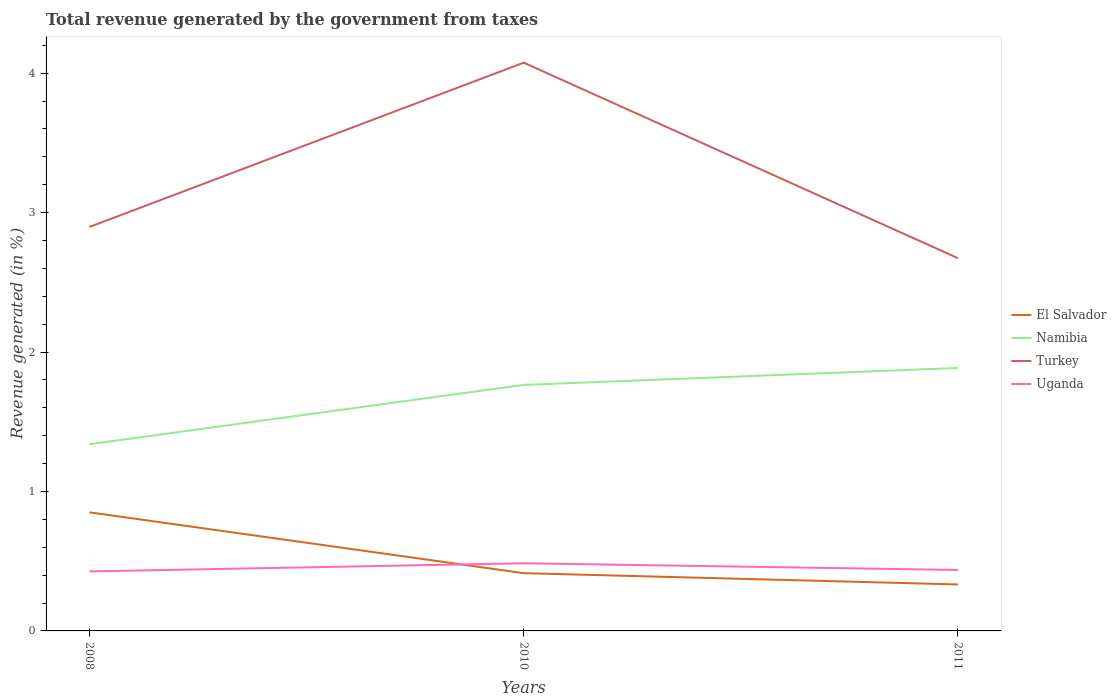Is the number of lines equal to the number of legend labels?
Provide a succinct answer. Yes. Across all years, what is the maximum total revenue generated in Turkey?
Your answer should be very brief. 2.67. What is the total total revenue generated in Turkey in the graph?
Make the answer very short. 1.4. What is the difference between the highest and the second highest total revenue generated in El Salvador?
Make the answer very short. 0.52. What is the difference between the highest and the lowest total revenue generated in Uganda?
Your response must be concise. 1. How many years are there in the graph?
Ensure brevity in your answer.  3. What is the difference between two consecutive major ticks on the Y-axis?
Keep it short and to the point. 1. Are the values on the major ticks of Y-axis written in scientific E-notation?
Offer a terse response. No. Does the graph contain grids?
Offer a terse response. No. How are the legend labels stacked?
Your answer should be very brief. Vertical. What is the title of the graph?
Offer a very short reply. Total revenue generated by the government from taxes. What is the label or title of the Y-axis?
Give a very brief answer. Revenue generated (in %). What is the Revenue generated (in %) in El Salvador in 2008?
Provide a short and direct response. 0.85. What is the Revenue generated (in %) of Namibia in 2008?
Your answer should be very brief. 1.34. What is the Revenue generated (in %) in Turkey in 2008?
Make the answer very short. 2.9. What is the Revenue generated (in %) of Uganda in 2008?
Make the answer very short. 0.43. What is the Revenue generated (in %) in El Salvador in 2010?
Provide a short and direct response. 0.41. What is the Revenue generated (in %) of Namibia in 2010?
Give a very brief answer. 1.76. What is the Revenue generated (in %) of Turkey in 2010?
Offer a terse response. 4.08. What is the Revenue generated (in %) of Uganda in 2010?
Your response must be concise. 0.49. What is the Revenue generated (in %) of El Salvador in 2011?
Your answer should be compact. 0.33. What is the Revenue generated (in %) of Namibia in 2011?
Provide a short and direct response. 1.89. What is the Revenue generated (in %) of Turkey in 2011?
Give a very brief answer. 2.67. What is the Revenue generated (in %) in Uganda in 2011?
Offer a very short reply. 0.44. Across all years, what is the maximum Revenue generated (in %) of El Salvador?
Make the answer very short. 0.85. Across all years, what is the maximum Revenue generated (in %) in Namibia?
Offer a terse response. 1.89. Across all years, what is the maximum Revenue generated (in %) in Turkey?
Ensure brevity in your answer.  4.08. Across all years, what is the maximum Revenue generated (in %) in Uganda?
Provide a short and direct response. 0.49. Across all years, what is the minimum Revenue generated (in %) in El Salvador?
Your answer should be compact. 0.33. Across all years, what is the minimum Revenue generated (in %) in Namibia?
Ensure brevity in your answer.  1.34. Across all years, what is the minimum Revenue generated (in %) in Turkey?
Offer a terse response. 2.67. Across all years, what is the minimum Revenue generated (in %) in Uganda?
Offer a terse response. 0.43. What is the total Revenue generated (in %) in El Salvador in the graph?
Keep it short and to the point. 1.6. What is the total Revenue generated (in %) in Namibia in the graph?
Provide a short and direct response. 4.99. What is the total Revenue generated (in %) of Turkey in the graph?
Offer a very short reply. 9.65. What is the total Revenue generated (in %) of Uganda in the graph?
Your response must be concise. 1.35. What is the difference between the Revenue generated (in %) in El Salvador in 2008 and that in 2010?
Give a very brief answer. 0.44. What is the difference between the Revenue generated (in %) in Namibia in 2008 and that in 2010?
Your answer should be very brief. -0.43. What is the difference between the Revenue generated (in %) in Turkey in 2008 and that in 2010?
Your answer should be compact. -1.18. What is the difference between the Revenue generated (in %) in Uganda in 2008 and that in 2010?
Ensure brevity in your answer.  -0.06. What is the difference between the Revenue generated (in %) in El Salvador in 2008 and that in 2011?
Provide a succinct answer. 0.52. What is the difference between the Revenue generated (in %) of Namibia in 2008 and that in 2011?
Your response must be concise. -0.55. What is the difference between the Revenue generated (in %) in Turkey in 2008 and that in 2011?
Your answer should be very brief. 0.22. What is the difference between the Revenue generated (in %) in Uganda in 2008 and that in 2011?
Your answer should be very brief. -0.01. What is the difference between the Revenue generated (in %) of El Salvador in 2010 and that in 2011?
Keep it short and to the point. 0.08. What is the difference between the Revenue generated (in %) of Namibia in 2010 and that in 2011?
Provide a short and direct response. -0.12. What is the difference between the Revenue generated (in %) in Turkey in 2010 and that in 2011?
Provide a short and direct response. 1.4. What is the difference between the Revenue generated (in %) in Uganda in 2010 and that in 2011?
Provide a succinct answer. 0.05. What is the difference between the Revenue generated (in %) of El Salvador in 2008 and the Revenue generated (in %) of Namibia in 2010?
Ensure brevity in your answer.  -0.91. What is the difference between the Revenue generated (in %) in El Salvador in 2008 and the Revenue generated (in %) in Turkey in 2010?
Your answer should be very brief. -3.22. What is the difference between the Revenue generated (in %) of El Salvador in 2008 and the Revenue generated (in %) of Uganda in 2010?
Keep it short and to the point. 0.37. What is the difference between the Revenue generated (in %) in Namibia in 2008 and the Revenue generated (in %) in Turkey in 2010?
Make the answer very short. -2.74. What is the difference between the Revenue generated (in %) in Namibia in 2008 and the Revenue generated (in %) in Uganda in 2010?
Offer a very short reply. 0.85. What is the difference between the Revenue generated (in %) of Turkey in 2008 and the Revenue generated (in %) of Uganda in 2010?
Ensure brevity in your answer.  2.41. What is the difference between the Revenue generated (in %) in El Salvador in 2008 and the Revenue generated (in %) in Namibia in 2011?
Give a very brief answer. -1.04. What is the difference between the Revenue generated (in %) in El Salvador in 2008 and the Revenue generated (in %) in Turkey in 2011?
Provide a short and direct response. -1.82. What is the difference between the Revenue generated (in %) in El Salvador in 2008 and the Revenue generated (in %) in Uganda in 2011?
Give a very brief answer. 0.41. What is the difference between the Revenue generated (in %) of Namibia in 2008 and the Revenue generated (in %) of Turkey in 2011?
Ensure brevity in your answer.  -1.33. What is the difference between the Revenue generated (in %) of Namibia in 2008 and the Revenue generated (in %) of Uganda in 2011?
Keep it short and to the point. 0.9. What is the difference between the Revenue generated (in %) of Turkey in 2008 and the Revenue generated (in %) of Uganda in 2011?
Make the answer very short. 2.46. What is the difference between the Revenue generated (in %) in El Salvador in 2010 and the Revenue generated (in %) in Namibia in 2011?
Give a very brief answer. -1.47. What is the difference between the Revenue generated (in %) in El Salvador in 2010 and the Revenue generated (in %) in Turkey in 2011?
Your response must be concise. -2.26. What is the difference between the Revenue generated (in %) in El Salvador in 2010 and the Revenue generated (in %) in Uganda in 2011?
Keep it short and to the point. -0.02. What is the difference between the Revenue generated (in %) of Namibia in 2010 and the Revenue generated (in %) of Turkey in 2011?
Make the answer very short. -0.91. What is the difference between the Revenue generated (in %) of Namibia in 2010 and the Revenue generated (in %) of Uganda in 2011?
Your answer should be compact. 1.33. What is the difference between the Revenue generated (in %) in Turkey in 2010 and the Revenue generated (in %) in Uganda in 2011?
Offer a very short reply. 3.64. What is the average Revenue generated (in %) in El Salvador per year?
Make the answer very short. 0.53. What is the average Revenue generated (in %) of Namibia per year?
Give a very brief answer. 1.66. What is the average Revenue generated (in %) of Turkey per year?
Give a very brief answer. 3.22. What is the average Revenue generated (in %) of Uganda per year?
Keep it short and to the point. 0.45. In the year 2008, what is the difference between the Revenue generated (in %) of El Salvador and Revenue generated (in %) of Namibia?
Your answer should be very brief. -0.49. In the year 2008, what is the difference between the Revenue generated (in %) of El Salvador and Revenue generated (in %) of Turkey?
Make the answer very short. -2.05. In the year 2008, what is the difference between the Revenue generated (in %) of El Salvador and Revenue generated (in %) of Uganda?
Provide a short and direct response. 0.42. In the year 2008, what is the difference between the Revenue generated (in %) in Namibia and Revenue generated (in %) in Turkey?
Provide a short and direct response. -1.56. In the year 2008, what is the difference between the Revenue generated (in %) in Namibia and Revenue generated (in %) in Uganda?
Make the answer very short. 0.91. In the year 2008, what is the difference between the Revenue generated (in %) of Turkey and Revenue generated (in %) of Uganda?
Your answer should be very brief. 2.47. In the year 2010, what is the difference between the Revenue generated (in %) of El Salvador and Revenue generated (in %) of Namibia?
Provide a succinct answer. -1.35. In the year 2010, what is the difference between the Revenue generated (in %) of El Salvador and Revenue generated (in %) of Turkey?
Provide a short and direct response. -3.66. In the year 2010, what is the difference between the Revenue generated (in %) of El Salvador and Revenue generated (in %) of Uganda?
Provide a succinct answer. -0.07. In the year 2010, what is the difference between the Revenue generated (in %) of Namibia and Revenue generated (in %) of Turkey?
Ensure brevity in your answer.  -2.31. In the year 2010, what is the difference between the Revenue generated (in %) of Namibia and Revenue generated (in %) of Uganda?
Make the answer very short. 1.28. In the year 2010, what is the difference between the Revenue generated (in %) in Turkey and Revenue generated (in %) in Uganda?
Ensure brevity in your answer.  3.59. In the year 2011, what is the difference between the Revenue generated (in %) in El Salvador and Revenue generated (in %) in Namibia?
Keep it short and to the point. -1.55. In the year 2011, what is the difference between the Revenue generated (in %) in El Salvador and Revenue generated (in %) in Turkey?
Give a very brief answer. -2.34. In the year 2011, what is the difference between the Revenue generated (in %) in El Salvador and Revenue generated (in %) in Uganda?
Your response must be concise. -0.1. In the year 2011, what is the difference between the Revenue generated (in %) of Namibia and Revenue generated (in %) of Turkey?
Your response must be concise. -0.79. In the year 2011, what is the difference between the Revenue generated (in %) in Namibia and Revenue generated (in %) in Uganda?
Provide a succinct answer. 1.45. In the year 2011, what is the difference between the Revenue generated (in %) in Turkey and Revenue generated (in %) in Uganda?
Provide a succinct answer. 2.24. What is the ratio of the Revenue generated (in %) of El Salvador in 2008 to that in 2010?
Give a very brief answer. 2.05. What is the ratio of the Revenue generated (in %) of Namibia in 2008 to that in 2010?
Your response must be concise. 0.76. What is the ratio of the Revenue generated (in %) of Turkey in 2008 to that in 2010?
Provide a short and direct response. 0.71. What is the ratio of the Revenue generated (in %) in Uganda in 2008 to that in 2010?
Offer a terse response. 0.88. What is the ratio of the Revenue generated (in %) of El Salvador in 2008 to that in 2011?
Ensure brevity in your answer.  2.55. What is the ratio of the Revenue generated (in %) in Namibia in 2008 to that in 2011?
Provide a short and direct response. 0.71. What is the ratio of the Revenue generated (in %) of Turkey in 2008 to that in 2011?
Provide a succinct answer. 1.08. What is the ratio of the Revenue generated (in %) in Uganda in 2008 to that in 2011?
Provide a short and direct response. 0.98. What is the ratio of the Revenue generated (in %) in El Salvador in 2010 to that in 2011?
Give a very brief answer. 1.24. What is the ratio of the Revenue generated (in %) of Namibia in 2010 to that in 2011?
Offer a terse response. 0.94. What is the ratio of the Revenue generated (in %) of Turkey in 2010 to that in 2011?
Your answer should be compact. 1.52. What is the ratio of the Revenue generated (in %) of Uganda in 2010 to that in 2011?
Your response must be concise. 1.11. What is the difference between the highest and the second highest Revenue generated (in %) of El Salvador?
Keep it short and to the point. 0.44. What is the difference between the highest and the second highest Revenue generated (in %) of Namibia?
Ensure brevity in your answer.  0.12. What is the difference between the highest and the second highest Revenue generated (in %) of Turkey?
Keep it short and to the point. 1.18. What is the difference between the highest and the second highest Revenue generated (in %) in Uganda?
Make the answer very short. 0.05. What is the difference between the highest and the lowest Revenue generated (in %) in El Salvador?
Your answer should be very brief. 0.52. What is the difference between the highest and the lowest Revenue generated (in %) of Namibia?
Give a very brief answer. 0.55. What is the difference between the highest and the lowest Revenue generated (in %) in Turkey?
Offer a very short reply. 1.4. What is the difference between the highest and the lowest Revenue generated (in %) in Uganda?
Offer a very short reply. 0.06. 